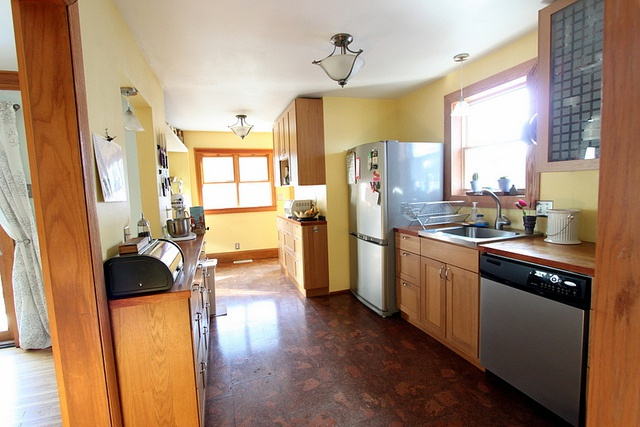Describe the objects in this image and their specific colors. I can see refrigerator in lightgray, darkgray, olive, and lightblue tones, oven in lightgray, black, and gray tones, sink in lightgray, gray, white, darkgray, and black tones, bowl in lightgray, gray, black, and maroon tones, and vase in lightgray, black, gray, and darkblue tones in this image. 